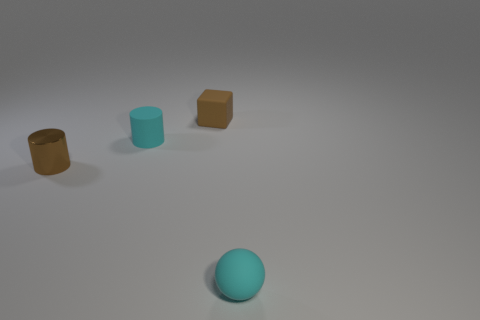What is the shape of the small thing that is the same color as the ball?
Give a very brief answer. Cylinder. How many small cyan cylinders have the same material as the small sphere?
Keep it short and to the point. 1. The shiny cylinder has what color?
Offer a very short reply. Brown. Does the brown object to the right of the tiny metallic cylinder have the same shape as the cyan object to the left of the sphere?
Your response must be concise. No. What color is the tiny metal cylinder that is to the left of the cyan matte cylinder?
Make the answer very short. Brown. Is the number of brown rubber objects that are left of the tiny matte block less than the number of brown blocks to the right of the shiny cylinder?
Make the answer very short. Yes. What number of other things are there of the same material as the tiny brown block
Offer a very short reply. 2. Are the cyan cylinder and the tiny brown cube made of the same material?
Provide a short and direct response. Yes. How big is the thing to the right of the object that is behind the cyan cylinder?
Your answer should be very brief. Small. There is a tiny object that is on the right side of the brown thing that is behind the cylinder that is on the right side of the small metallic thing; what color is it?
Your answer should be compact. Cyan. 